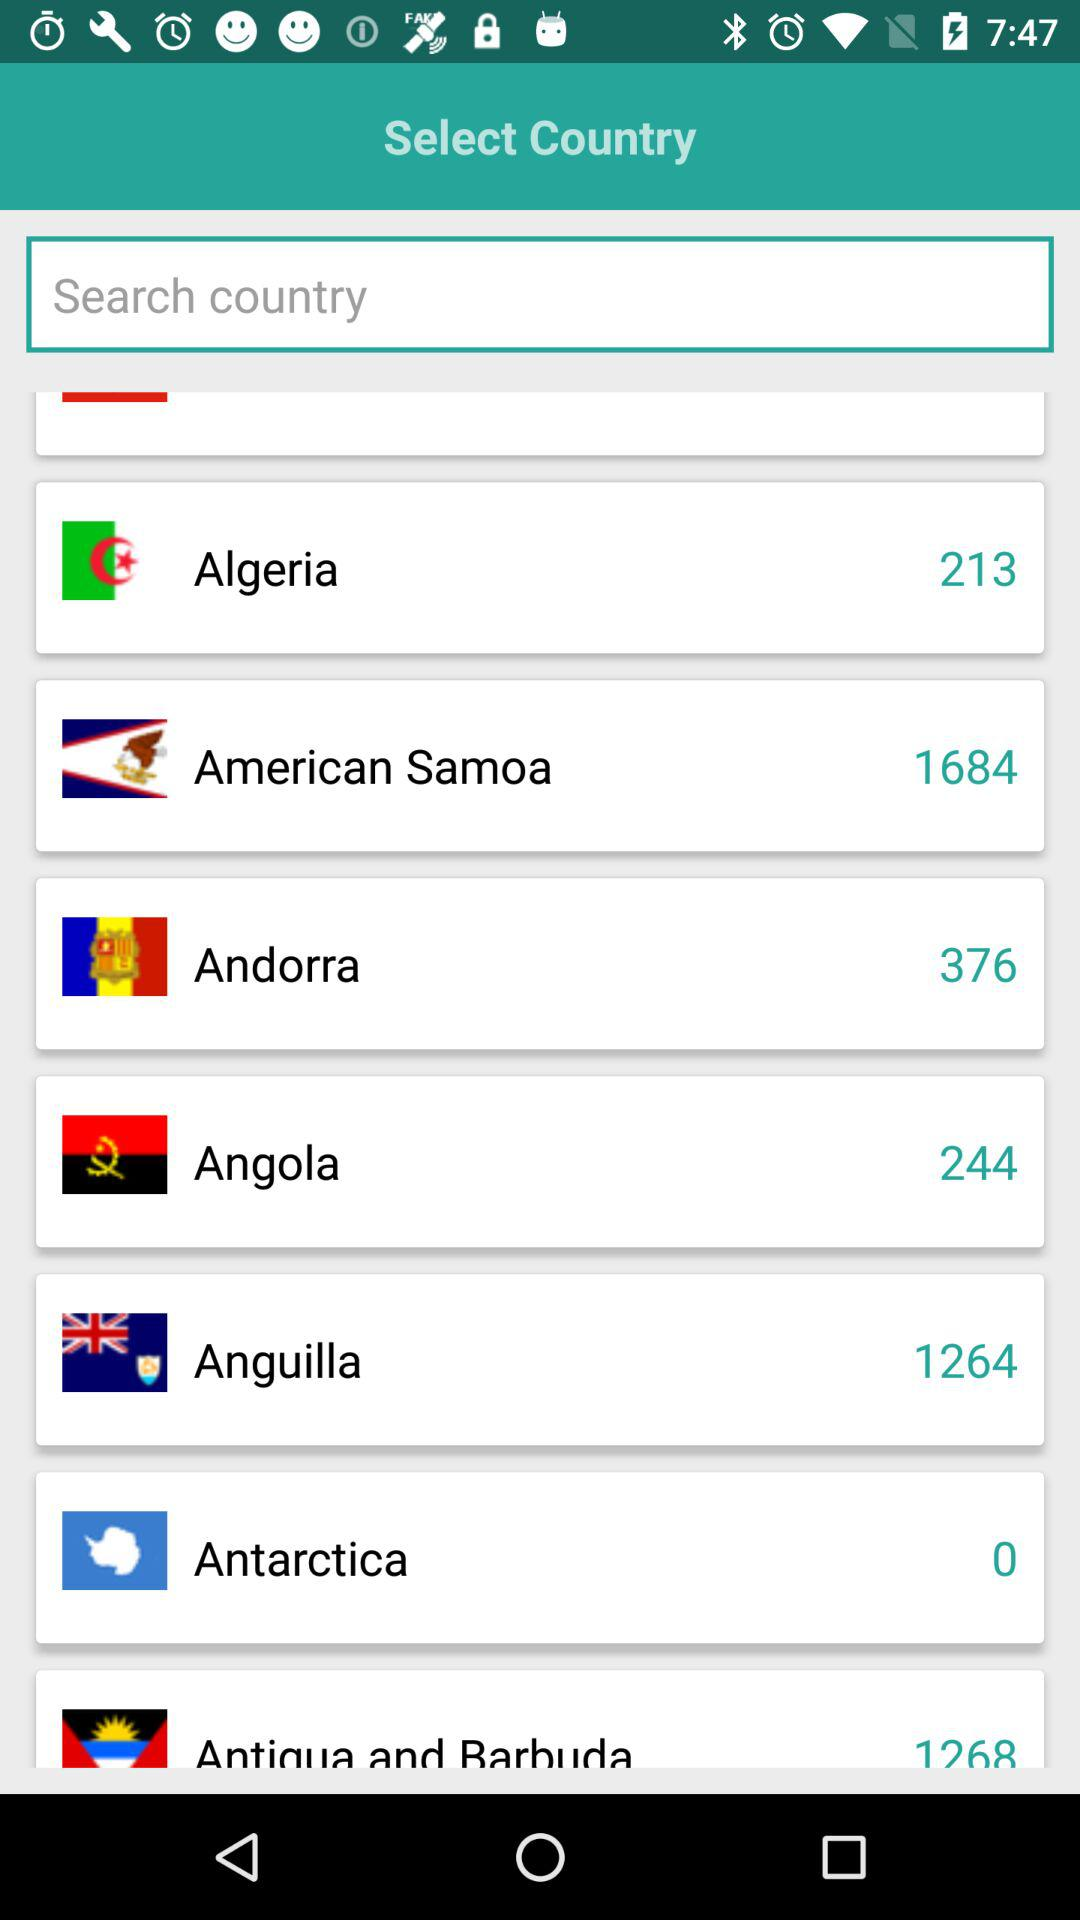What is the country code given for Angola? The country code given for Angola is 244. 